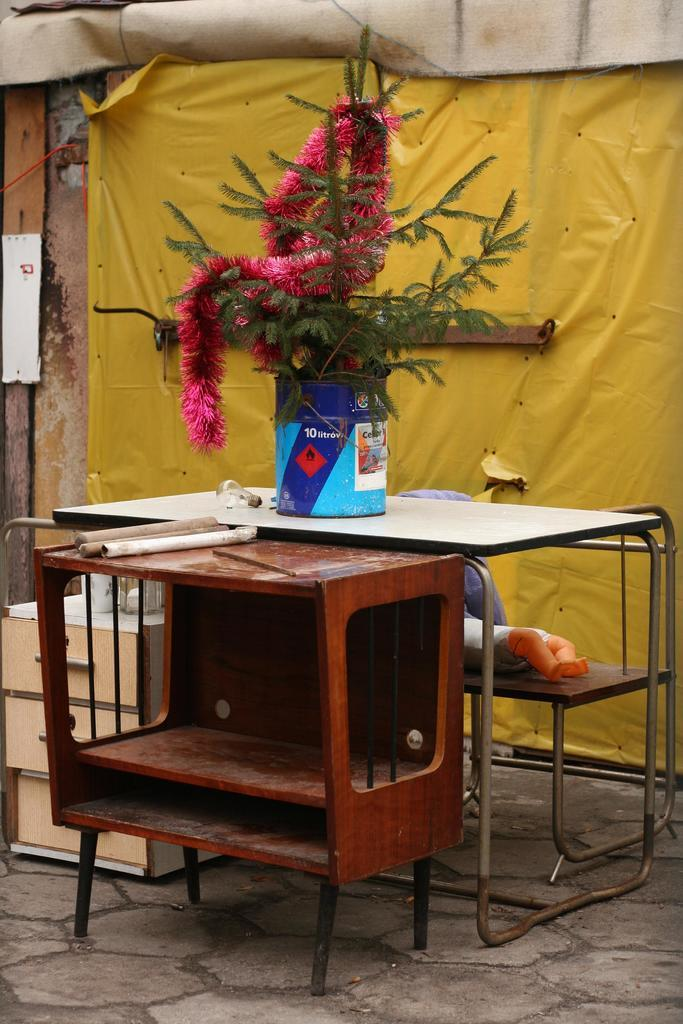What is the main piece of furniture in the image? There is a table in the image. What objects are placed on the table? There is a plant and a doll on the table. What color is the cover on the wall behind the table? There is a yellow color cover on the wall behind the table. How many dimes are placed on the table in the image? There are no dimes present in the image; it features a table with a plant and a doll. 